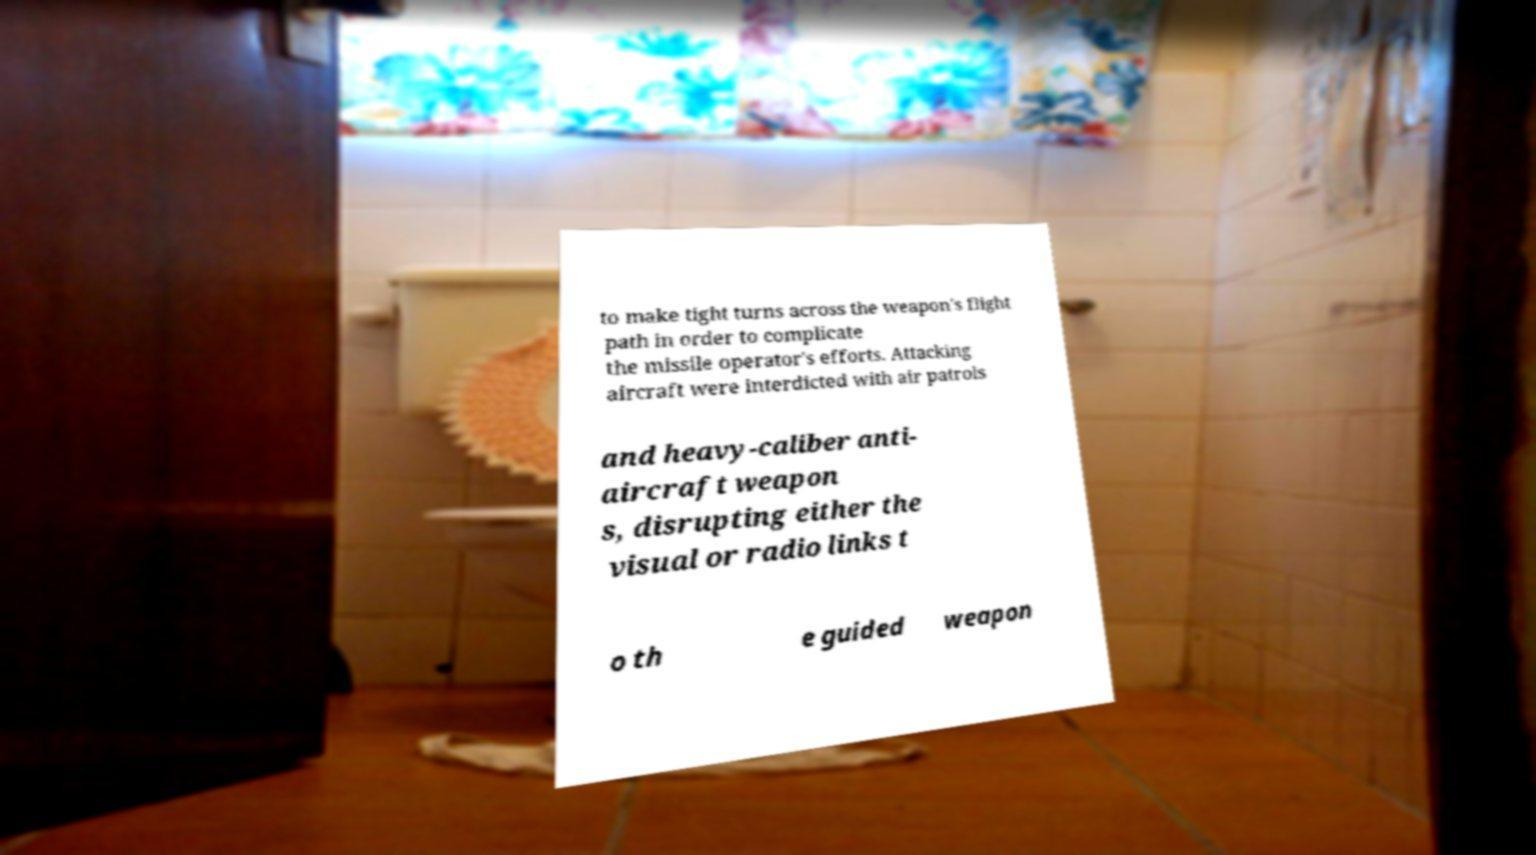There's text embedded in this image that I need extracted. Can you transcribe it verbatim? to make tight turns across the weapon's flight path in order to complicate the missile operator's efforts. Attacking aircraft were interdicted with air patrols and heavy-caliber anti- aircraft weapon s, disrupting either the visual or radio links t o th e guided weapon 